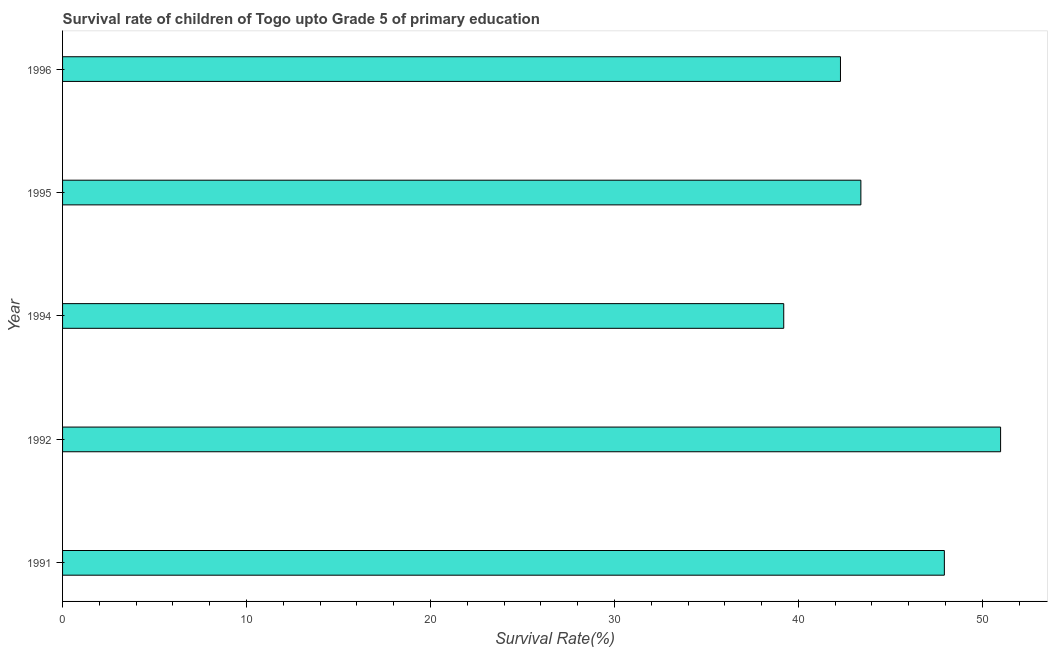What is the title of the graph?
Your answer should be compact. Survival rate of children of Togo upto Grade 5 of primary education. What is the label or title of the X-axis?
Ensure brevity in your answer.  Survival Rate(%). What is the survival rate in 1995?
Ensure brevity in your answer.  43.4. Across all years, what is the maximum survival rate?
Make the answer very short. 50.99. Across all years, what is the minimum survival rate?
Offer a very short reply. 39.2. In which year was the survival rate maximum?
Provide a short and direct response. 1992. What is the sum of the survival rate?
Offer a very short reply. 223.81. What is the difference between the survival rate in 1992 and 1995?
Give a very brief answer. 7.59. What is the average survival rate per year?
Keep it short and to the point. 44.76. What is the median survival rate?
Ensure brevity in your answer.  43.4. In how many years, is the survival rate greater than 26 %?
Provide a succinct answer. 5. What is the ratio of the survival rate in 1994 to that in 1996?
Offer a very short reply. 0.93. Is the difference between the survival rate in 1992 and 1995 greater than the difference between any two years?
Your answer should be compact. No. What is the difference between the highest and the second highest survival rate?
Provide a short and direct response. 3.06. Is the sum of the survival rate in 1995 and 1996 greater than the maximum survival rate across all years?
Keep it short and to the point. Yes. What is the difference between the highest and the lowest survival rate?
Your answer should be very brief. 11.79. In how many years, is the survival rate greater than the average survival rate taken over all years?
Offer a terse response. 2. How many bars are there?
Your answer should be very brief. 5. Are all the bars in the graph horizontal?
Offer a very short reply. Yes. How many years are there in the graph?
Ensure brevity in your answer.  5. What is the Survival Rate(%) of 1991?
Ensure brevity in your answer.  47.93. What is the Survival Rate(%) in 1992?
Your response must be concise. 50.99. What is the Survival Rate(%) of 1994?
Offer a terse response. 39.2. What is the Survival Rate(%) in 1995?
Offer a very short reply. 43.4. What is the Survival Rate(%) of 1996?
Keep it short and to the point. 42.29. What is the difference between the Survival Rate(%) in 1991 and 1992?
Provide a short and direct response. -3.06. What is the difference between the Survival Rate(%) in 1991 and 1994?
Ensure brevity in your answer.  8.73. What is the difference between the Survival Rate(%) in 1991 and 1995?
Give a very brief answer. 4.54. What is the difference between the Survival Rate(%) in 1991 and 1996?
Offer a terse response. 5.65. What is the difference between the Survival Rate(%) in 1992 and 1994?
Your answer should be very brief. 11.79. What is the difference between the Survival Rate(%) in 1992 and 1995?
Provide a succinct answer. 7.59. What is the difference between the Survival Rate(%) in 1992 and 1996?
Keep it short and to the point. 8.7. What is the difference between the Survival Rate(%) in 1994 and 1995?
Ensure brevity in your answer.  -4.19. What is the difference between the Survival Rate(%) in 1994 and 1996?
Offer a very short reply. -3.08. What is the difference between the Survival Rate(%) in 1995 and 1996?
Offer a terse response. 1.11. What is the ratio of the Survival Rate(%) in 1991 to that in 1994?
Keep it short and to the point. 1.22. What is the ratio of the Survival Rate(%) in 1991 to that in 1995?
Ensure brevity in your answer.  1.1. What is the ratio of the Survival Rate(%) in 1991 to that in 1996?
Ensure brevity in your answer.  1.13. What is the ratio of the Survival Rate(%) in 1992 to that in 1994?
Provide a succinct answer. 1.3. What is the ratio of the Survival Rate(%) in 1992 to that in 1995?
Provide a succinct answer. 1.18. What is the ratio of the Survival Rate(%) in 1992 to that in 1996?
Make the answer very short. 1.21. What is the ratio of the Survival Rate(%) in 1994 to that in 1995?
Offer a very short reply. 0.9. What is the ratio of the Survival Rate(%) in 1994 to that in 1996?
Provide a short and direct response. 0.93. 